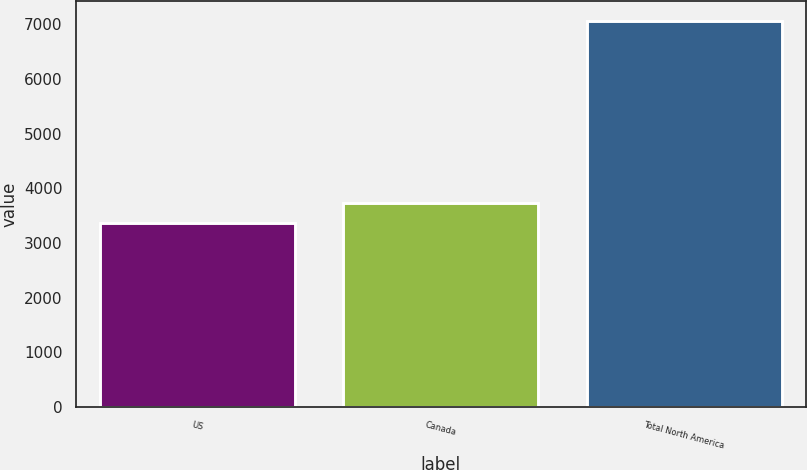Convert chart. <chart><loc_0><loc_0><loc_500><loc_500><bar_chart><fcel>US<fcel>Canada<fcel>Total North America<nl><fcel>3366<fcel>3735.9<fcel>7065<nl></chart> 